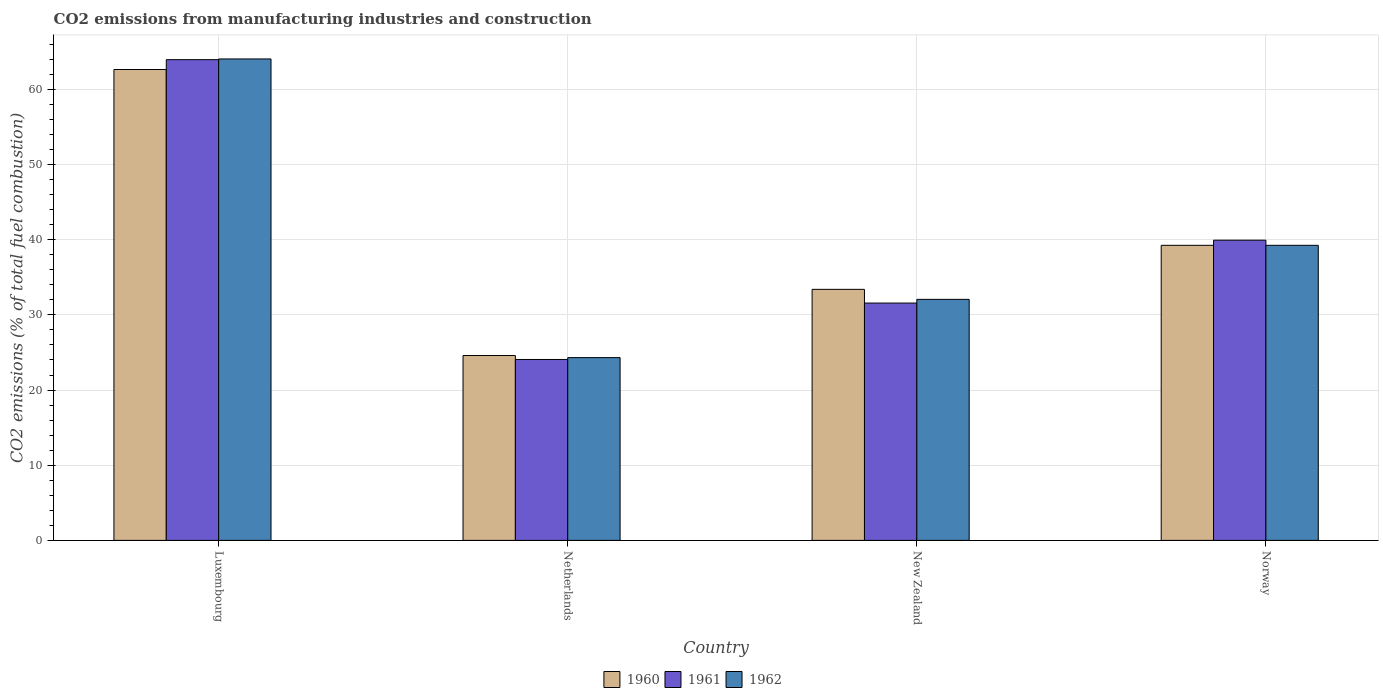Are the number of bars per tick equal to the number of legend labels?
Offer a terse response. Yes. Are the number of bars on each tick of the X-axis equal?
Make the answer very short. Yes. How many bars are there on the 3rd tick from the right?
Make the answer very short. 3. What is the label of the 1st group of bars from the left?
Keep it short and to the point. Luxembourg. What is the amount of CO2 emitted in 1961 in Luxembourg?
Ensure brevity in your answer.  63.95. Across all countries, what is the maximum amount of CO2 emitted in 1961?
Give a very brief answer. 63.95. Across all countries, what is the minimum amount of CO2 emitted in 1962?
Keep it short and to the point. 24.32. In which country was the amount of CO2 emitted in 1960 maximum?
Make the answer very short. Luxembourg. In which country was the amount of CO2 emitted in 1962 minimum?
Ensure brevity in your answer.  Netherlands. What is the total amount of CO2 emitted in 1962 in the graph?
Provide a short and direct response. 159.69. What is the difference between the amount of CO2 emitted in 1962 in Luxembourg and that in New Zealand?
Your response must be concise. 31.98. What is the difference between the amount of CO2 emitted in 1962 in Luxembourg and the amount of CO2 emitted in 1960 in New Zealand?
Ensure brevity in your answer.  30.65. What is the average amount of CO2 emitted in 1962 per country?
Ensure brevity in your answer.  39.92. What is the difference between the amount of CO2 emitted of/in 1962 and amount of CO2 emitted of/in 1961 in Norway?
Give a very brief answer. -0.68. In how many countries, is the amount of CO2 emitted in 1960 greater than 14 %?
Offer a terse response. 4. What is the ratio of the amount of CO2 emitted in 1962 in Luxembourg to that in Norway?
Your answer should be very brief. 1.63. Is the amount of CO2 emitted in 1961 in Luxembourg less than that in New Zealand?
Give a very brief answer. No. Is the difference between the amount of CO2 emitted in 1962 in Luxembourg and New Zealand greater than the difference between the amount of CO2 emitted in 1961 in Luxembourg and New Zealand?
Give a very brief answer. No. What is the difference between the highest and the second highest amount of CO2 emitted in 1961?
Your response must be concise. -8.36. What is the difference between the highest and the lowest amount of CO2 emitted in 1961?
Keep it short and to the point. 39.89. In how many countries, is the amount of CO2 emitted in 1961 greater than the average amount of CO2 emitted in 1961 taken over all countries?
Offer a terse response. 2. Is it the case that in every country, the sum of the amount of CO2 emitted in 1962 and amount of CO2 emitted in 1961 is greater than the amount of CO2 emitted in 1960?
Your answer should be very brief. Yes. How many countries are there in the graph?
Provide a succinct answer. 4. What is the difference between two consecutive major ticks on the Y-axis?
Provide a short and direct response. 10. Does the graph contain any zero values?
Your answer should be very brief. No. How many legend labels are there?
Make the answer very short. 3. How are the legend labels stacked?
Offer a very short reply. Horizontal. What is the title of the graph?
Offer a very short reply. CO2 emissions from manufacturing industries and construction. Does "1975" appear as one of the legend labels in the graph?
Your answer should be very brief. No. What is the label or title of the Y-axis?
Ensure brevity in your answer.  CO2 emissions (% of total fuel combustion). What is the CO2 emissions (% of total fuel combustion) in 1960 in Luxembourg?
Provide a short and direct response. 62.65. What is the CO2 emissions (% of total fuel combustion) of 1961 in Luxembourg?
Provide a succinct answer. 63.95. What is the CO2 emissions (% of total fuel combustion) in 1962 in Luxembourg?
Make the answer very short. 64.05. What is the CO2 emissions (% of total fuel combustion) in 1960 in Netherlands?
Your answer should be compact. 24.59. What is the CO2 emissions (% of total fuel combustion) of 1961 in Netherlands?
Ensure brevity in your answer.  24.07. What is the CO2 emissions (% of total fuel combustion) of 1962 in Netherlands?
Provide a short and direct response. 24.32. What is the CO2 emissions (% of total fuel combustion) of 1960 in New Zealand?
Provide a short and direct response. 33.4. What is the CO2 emissions (% of total fuel combustion) in 1961 in New Zealand?
Provide a short and direct response. 31.57. What is the CO2 emissions (% of total fuel combustion) of 1962 in New Zealand?
Give a very brief answer. 32.07. What is the CO2 emissions (% of total fuel combustion) of 1960 in Norway?
Your response must be concise. 39.26. What is the CO2 emissions (% of total fuel combustion) of 1961 in Norway?
Keep it short and to the point. 39.94. What is the CO2 emissions (% of total fuel combustion) in 1962 in Norway?
Make the answer very short. 39.26. Across all countries, what is the maximum CO2 emissions (% of total fuel combustion) in 1960?
Make the answer very short. 62.65. Across all countries, what is the maximum CO2 emissions (% of total fuel combustion) in 1961?
Your answer should be compact. 63.95. Across all countries, what is the maximum CO2 emissions (% of total fuel combustion) in 1962?
Offer a very short reply. 64.05. Across all countries, what is the minimum CO2 emissions (% of total fuel combustion) of 1960?
Ensure brevity in your answer.  24.59. Across all countries, what is the minimum CO2 emissions (% of total fuel combustion) of 1961?
Offer a very short reply. 24.07. Across all countries, what is the minimum CO2 emissions (% of total fuel combustion) of 1962?
Ensure brevity in your answer.  24.32. What is the total CO2 emissions (% of total fuel combustion) of 1960 in the graph?
Your response must be concise. 159.89. What is the total CO2 emissions (% of total fuel combustion) in 1961 in the graph?
Your response must be concise. 159.54. What is the total CO2 emissions (% of total fuel combustion) of 1962 in the graph?
Provide a succinct answer. 159.69. What is the difference between the CO2 emissions (% of total fuel combustion) in 1960 in Luxembourg and that in Netherlands?
Offer a terse response. 38.05. What is the difference between the CO2 emissions (% of total fuel combustion) in 1961 in Luxembourg and that in Netherlands?
Provide a short and direct response. 39.88. What is the difference between the CO2 emissions (% of total fuel combustion) of 1962 in Luxembourg and that in Netherlands?
Your answer should be compact. 39.73. What is the difference between the CO2 emissions (% of total fuel combustion) of 1960 in Luxembourg and that in New Zealand?
Ensure brevity in your answer.  29.25. What is the difference between the CO2 emissions (% of total fuel combustion) in 1961 in Luxembourg and that in New Zealand?
Keep it short and to the point. 32.38. What is the difference between the CO2 emissions (% of total fuel combustion) in 1962 in Luxembourg and that in New Zealand?
Make the answer very short. 31.98. What is the difference between the CO2 emissions (% of total fuel combustion) in 1960 in Luxembourg and that in Norway?
Ensure brevity in your answer.  23.39. What is the difference between the CO2 emissions (% of total fuel combustion) in 1961 in Luxembourg and that in Norway?
Provide a succinct answer. 24.02. What is the difference between the CO2 emissions (% of total fuel combustion) of 1962 in Luxembourg and that in Norway?
Offer a very short reply. 24.79. What is the difference between the CO2 emissions (% of total fuel combustion) of 1960 in Netherlands and that in New Zealand?
Offer a very short reply. -8.8. What is the difference between the CO2 emissions (% of total fuel combustion) in 1961 in Netherlands and that in New Zealand?
Offer a very short reply. -7.5. What is the difference between the CO2 emissions (% of total fuel combustion) in 1962 in Netherlands and that in New Zealand?
Keep it short and to the point. -7.75. What is the difference between the CO2 emissions (% of total fuel combustion) of 1960 in Netherlands and that in Norway?
Your answer should be compact. -14.66. What is the difference between the CO2 emissions (% of total fuel combustion) in 1961 in Netherlands and that in Norway?
Ensure brevity in your answer.  -15.87. What is the difference between the CO2 emissions (% of total fuel combustion) of 1962 in Netherlands and that in Norway?
Offer a terse response. -14.94. What is the difference between the CO2 emissions (% of total fuel combustion) of 1960 in New Zealand and that in Norway?
Make the answer very short. -5.86. What is the difference between the CO2 emissions (% of total fuel combustion) of 1961 in New Zealand and that in Norway?
Your response must be concise. -8.36. What is the difference between the CO2 emissions (% of total fuel combustion) in 1962 in New Zealand and that in Norway?
Ensure brevity in your answer.  -7.19. What is the difference between the CO2 emissions (% of total fuel combustion) in 1960 in Luxembourg and the CO2 emissions (% of total fuel combustion) in 1961 in Netherlands?
Ensure brevity in your answer.  38.58. What is the difference between the CO2 emissions (% of total fuel combustion) of 1960 in Luxembourg and the CO2 emissions (% of total fuel combustion) of 1962 in Netherlands?
Make the answer very short. 38.33. What is the difference between the CO2 emissions (% of total fuel combustion) in 1961 in Luxembourg and the CO2 emissions (% of total fuel combustion) in 1962 in Netherlands?
Provide a succinct answer. 39.64. What is the difference between the CO2 emissions (% of total fuel combustion) of 1960 in Luxembourg and the CO2 emissions (% of total fuel combustion) of 1961 in New Zealand?
Provide a short and direct response. 31.07. What is the difference between the CO2 emissions (% of total fuel combustion) of 1960 in Luxembourg and the CO2 emissions (% of total fuel combustion) of 1962 in New Zealand?
Keep it short and to the point. 30.58. What is the difference between the CO2 emissions (% of total fuel combustion) of 1961 in Luxembourg and the CO2 emissions (% of total fuel combustion) of 1962 in New Zealand?
Offer a terse response. 31.89. What is the difference between the CO2 emissions (% of total fuel combustion) in 1960 in Luxembourg and the CO2 emissions (% of total fuel combustion) in 1961 in Norway?
Your answer should be very brief. 22.71. What is the difference between the CO2 emissions (% of total fuel combustion) of 1960 in Luxembourg and the CO2 emissions (% of total fuel combustion) of 1962 in Norway?
Make the answer very short. 23.39. What is the difference between the CO2 emissions (% of total fuel combustion) of 1961 in Luxembourg and the CO2 emissions (% of total fuel combustion) of 1962 in Norway?
Your answer should be very brief. 24.7. What is the difference between the CO2 emissions (% of total fuel combustion) in 1960 in Netherlands and the CO2 emissions (% of total fuel combustion) in 1961 in New Zealand?
Your answer should be very brief. -6.98. What is the difference between the CO2 emissions (% of total fuel combustion) in 1960 in Netherlands and the CO2 emissions (% of total fuel combustion) in 1962 in New Zealand?
Offer a very short reply. -7.47. What is the difference between the CO2 emissions (% of total fuel combustion) in 1961 in Netherlands and the CO2 emissions (% of total fuel combustion) in 1962 in New Zealand?
Your answer should be very brief. -8. What is the difference between the CO2 emissions (% of total fuel combustion) of 1960 in Netherlands and the CO2 emissions (% of total fuel combustion) of 1961 in Norway?
Your response must be concise. -15.34. What is the difference between the CO2 emissions (% of total fuel combustion) of 1960 in Netherlands and the CO2 emissions (% of total fuel combustion) of 1962 in Norway?
Ensure brevity in your answer.  -14.66. What is the difference between the CO2 emissions (% of total fuel combustion) in 1961 in Netherlands and the CO2 emissions (% of total fuel combustion) in 1962 in Norway?
Your answer should be very brief. -15.19. What is the difference between the CO2 emissions (% of total fuel combustion) of 1960 in New Zealand and the CO2 emissions (% of total fuel combustion) of 1961 in Norway?
Your answer should be compact. -6.54. What is the difference between the CO2 emissions (% of total fuel combustion) in 1960 in New Zealand and the CO2 emissions (% of total fuel combustion) in 1962 in Norway?
Your answer should be compact. -5.86. What is the difference between the CO2 emissions (% of total fuel combustion) in 1961 in New Zealand and the CO2 emissions (% of total fuel combustion) in 1962 in Norway?
Your answer should be very brief. -7.68. What is the average CO2 emissions (% of total fuel combustion) in 1960 per country?
Offer a very short reply. 39.97. What is the average CO2 emissions (% of total fuel combustion) of 1961 per country?
Your response must be concise. 39.88. What is the average CO2 emissions (% of total fuel combustion) in 1962 per country?
Keep it short and to the point. 39.92. What is the difference between the CO2 emissions (% of total fuel combustion) in 1960 and CO2 emissions (% of total fuel combustion) in 1961 in Luxembourg?
Provide a succinct answer. -1.31. What is the difference between the CO2 emissions (% of total fuel combustion) in 1960 and CO2 emissions (% of total fuel combustion) in 1962 in Luxembourg?
Offer a terse response. -1.4. What is the difference between the CO2 emissions (% of total fuel combustion) in 1961 and CO2 emissions (% of total fuel combustion) in 1962 in Luxembourg?
Your response must be concise. -0.1. What is the difference between the CO2 emissions (% of total fuel combustion) of 1960 and CO2 emissions (% of total fuel combustion) of 1961 in Netherlands?
Give a very brief answer. 0.52. What is the difference between the CO2 emissions (% of total fuel combustion) in 1960 and CO2 emissions (% of total fuel combustion) in 1962 in Netherlands?
Offer a terse response. 0.28. What is the difference between the CO2 emissions (% of total fuel combustion) of 1961 and CO2 emissions (% of total fuel combustion) of 1962 in Netherlands?
Keep it short and to the point. -0.25. What is the difference between the CO2 emissions (% of total fuel combustion) in 1960 and CO2 emissions (% of total fuel combustion) in 1961 in New Zealand?
Provide a short and direct response. 1.82. What is the difference between the CO2 emissions (% of total fuel combustion) in 1960 and CO2 emissions (% of total fuel combustion) in 1962 in New Zealand?
Offer a terse response. 1.33. What is the difference between the CO2 emissions (% of total fuel combustion) in 1961 and CO2 emissions (% of total fuel combustion) in 1962 in New Zealand?
Provide a succinct answer. -0.49. What is the difference between the CO2 emissions (% of total fuel combustion) of 1960 and CO2 emissions (% of total fuel combustion) of 1961 in Norway?
Your response must be concise. -0.68. What is the difference between the CO2 emissions (% of total fuel combustion) of 1960 and CO2 emissions (% of total fuel combustion) of 1962 in Norway?
Your answer should be compact. 0. What is the difference between the CO2 emissions (% of total fuel combustion) of 1961 and CO2 emissions (% of total fuel combustion) of 1962 in Norway?
Your response must be concise. 0.68. What is the ratio of the CO2 emissions (% of total fuel combustion) in 1960 in Luxembourg to that in Netherlands?
Your response must be concise. 2.55. What is the ratio of the CO2 emissions (% of total fuel combustion) in 1961 in Luxembourg to that in Netherlands?
Your response must be concise. 2.66. What is the ratio of the CO2 emissions (% of total fuel combustion) of 1962 in Luxembourg to that in Netherlands?
Offer a terse response. 2.63. What is the ratio of the CO2 emissions (% of total fuel combustion) of 1960 in Luxembourg to that in New Zealand?
Provide a succinct answer. 1.88. What is the ratio of the CO2 emissions (% of total fuel combustion) in 1961 in Luxembourg to that in New Zealand?
Provide a succinct answer. 2.03. What is the ratio of the CO2 emissions (% of total fuel combustion) of 1962 in Luxembourg to that in New Zealand?
Your answer should be very brief. 2. What is the ratio of the CO2 emissions (% of total fuel combustion) in 1960 in Luxembourg to that in Norway?
Offer a very short reply. 1.6. What is the ratio of the CO2 emissions (% of total fuel combustion) of 1961 in Luxembourg to that in Norway?
Ensure brevity in your answer.  1.6. What is the ratio of the CO2 emissions (% of total fuel combustion) of 1962 in Luxembourg to that in Norway?
Offer a terse response. 1.63. What is the ratio of the CO2 emissions (% of total fuel combustion) in 1960 in Netherlands to that in New Zealand?
Keep it short and to the point. 0.74. What is the ratio of the CO2 emissions (% of total fuel combustion) in 1961 in Netherlands to that in New Zealand?
Your response must be concise. 0.76. What is the ratio of the CO2 emissions (% of total fuel combustion) of 1962 in Netherlands to that in New Zealand?
Provide a short and direct response. 0.76. What is the ratio of the CO2 emissions (% of total fuel combustion) of 1960 in Netherlands to that in Norway?
Your answer should be compact. 0.63. What is the ratio of the CO2 emissions (% of total fuel combustion) of 1961 in Netherlands to that in Norway?
Ensure brevity in your answer.  0.6. What is the ratio of the CO2 emissions (% of total fuel combustion) of 1962 in Netherlands to that in Norway?
Provide a succinct answer. 0.62. What is the ratio of the CO2 emissions (% of total fuel combustion) of 1960 in New Zealand to that in Norway?
Keep it short and to the point. 0.85. What is the ratio of the CO2 emissions (% of total fuel combustion) in 1961 in New Zealand to that in Norway?
Your response must be concise. 0.79. What is the ratio of the CO2 emissions (% of total fuel combustion) of 1962 in New Zealand to that in Norway?
Offer a very short reply. 0.82. What is the difference between the highest and the second highest CO2 emissions (% of total fuel combustion) of 1960?
Provide a succinct answer. 23.39. What is the difference between the highest and the second highest CO2 emissions (% of total fuel combustion) of 1961?
Offer a very short reply. 24.02. What is the difference between the highest and the second highest CO2 emissions (% of total fuel combustion) of 1962?
Offer a very short reply. 24.79. What is the difference between the highest and the lowest CO2 emissions (% of total fuel combustion) of 1960?
Keep it short and to the point. 38.05. What is the difference between the highest and the lowest CO2 emissions (% of total fuel combustion) in 1961?
Provide a succinct answer. 39.88. What is the difference between the highest and the lowest CO2 emissions (% of total fuel combustion) of 1962?
Offer a very short reply. 39.73. 